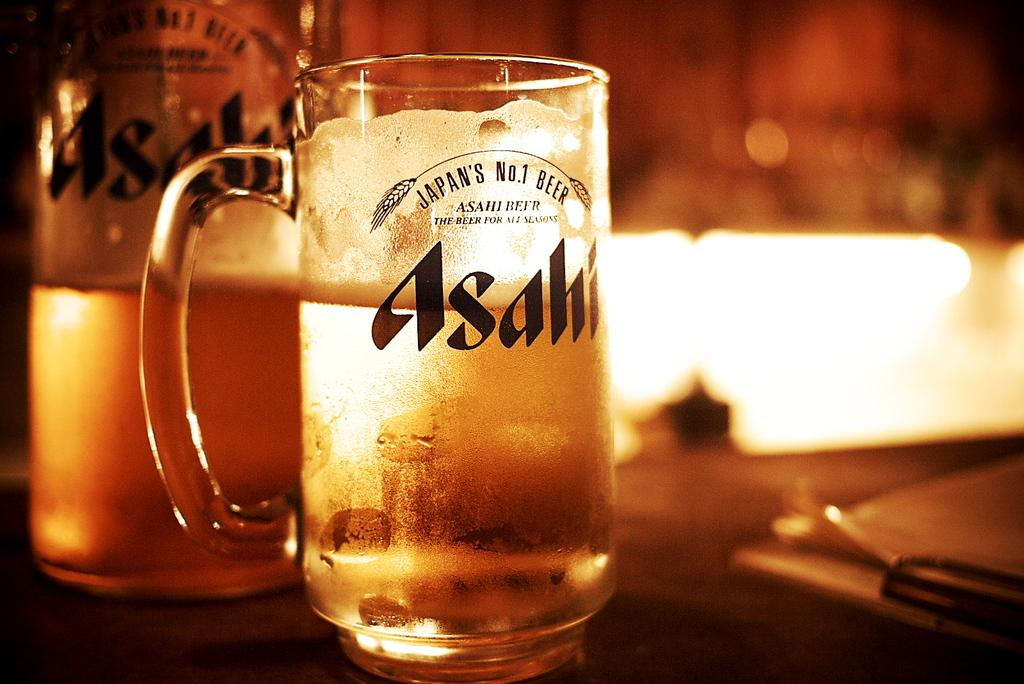<image>
Provide a brief description of the given image. A frosty cold mug of beer has the name of the Asahi company on it. 